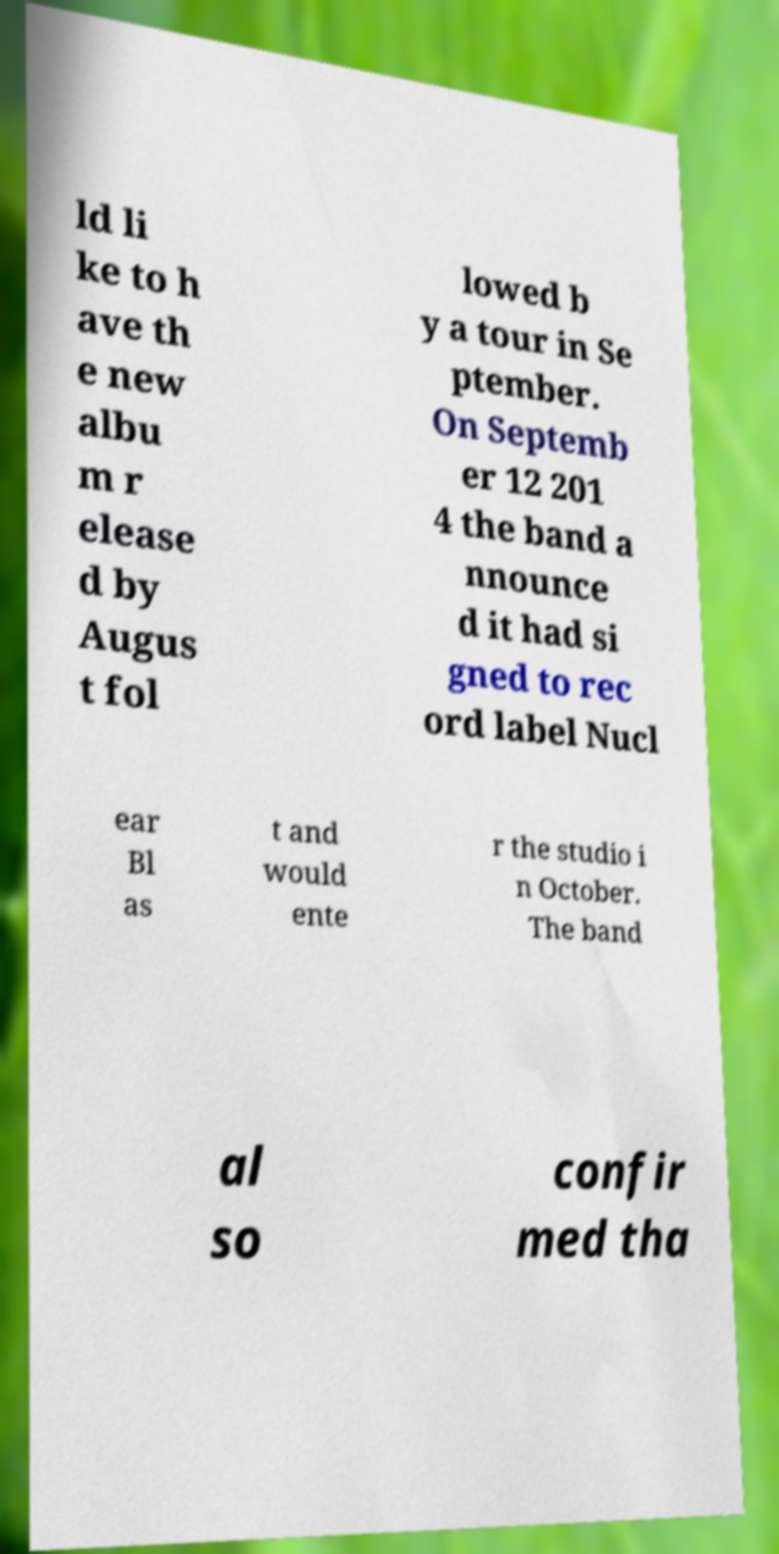What messages or text are displayed in this image? I need them in a readable, typed format. ld li ke to h ave th e new albu m r elease d by Augus t fol lowed b y a tour in Se ptember. On Septemb er 12 201 4 the band a nnounce d it had si gned to rec ord label Nucl ear Bl as t and would ente r the studio i n October. The band al so confir med tha 